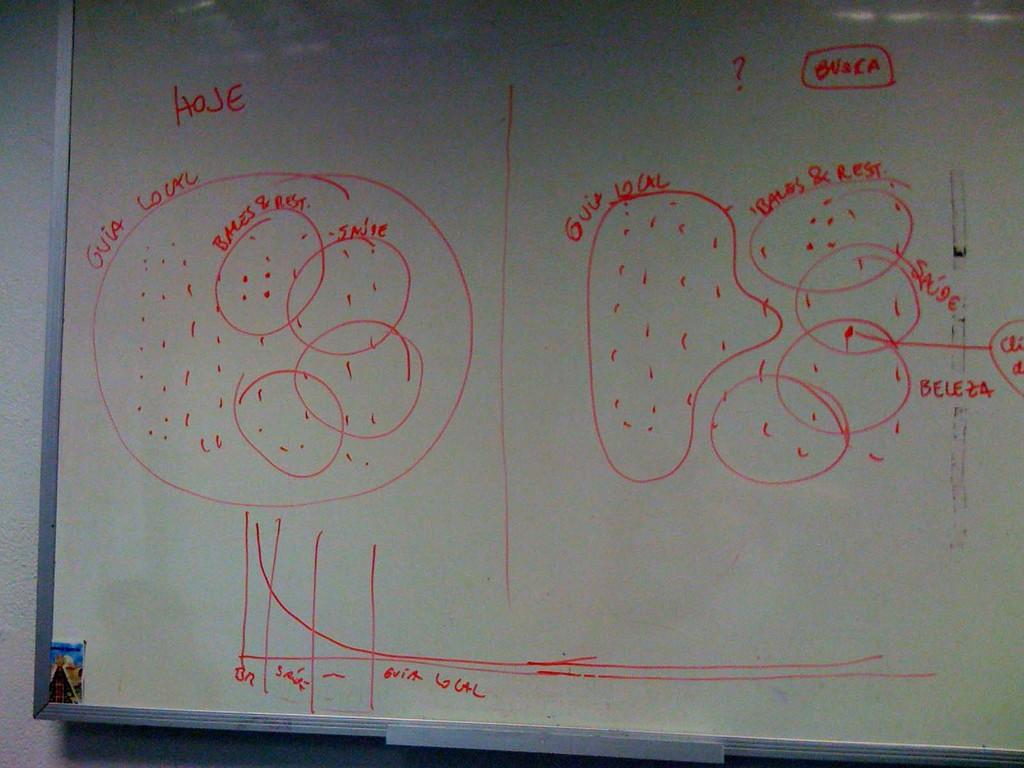What is depicted on the whiteboard in the image? There is an art on a whiteboard in the image. What elements are included in the art? The art includes text and a drawing. Where is the nest located in the image? There is no nest present in the image. What kind of trouble is the aunt experiencing in the image? There is no aunt or any indication of trouble in the image. 